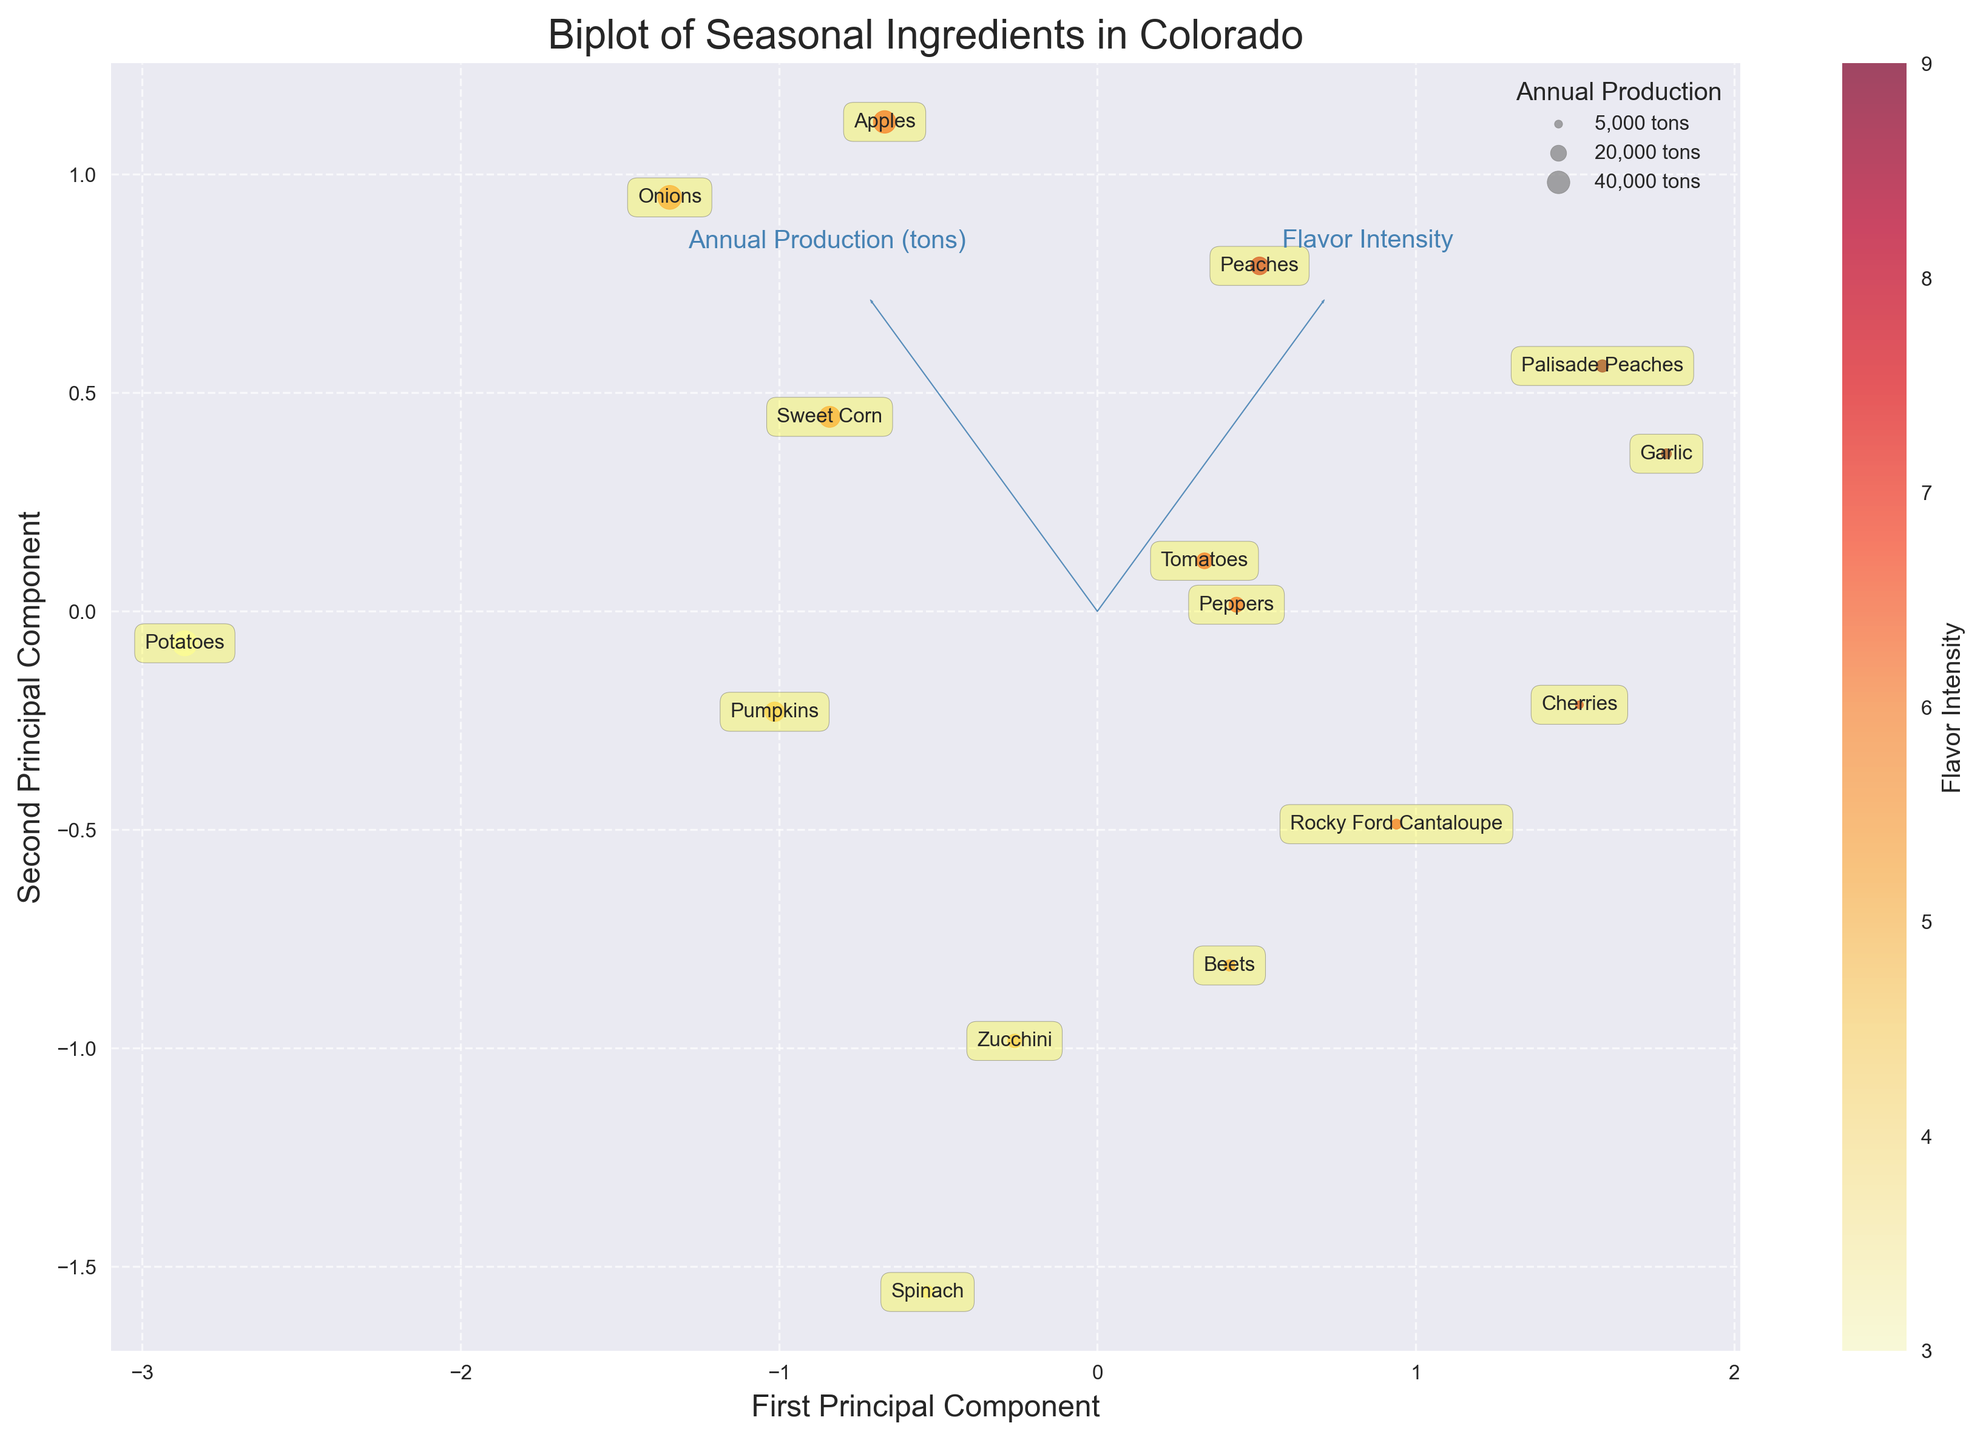What is the title of the biplot? The title of a figure is usually located at the top center of the plot. In this case, it should match what was set in the code.
Answer: Biplot of Seasonal Ingredients in Colorado How many ingredients are shown in the plot? To count the number of ingredients, look at the number of data points with labels in the plot. Each labeled point represents an ingredient.
Answer: 14 Which ingredient has the highest flavor intensity? The ingredient with the highest flavor intensity will be indicated by the color scale (cmap='YlOrRd'). Look for the darkest colored point on the plot.
Answer: Garlic What is the range of the first principal component? To determine the range of the first principal component, observe the x-axis limits marked on the plot.
Answer: Approximately -2 to 2 Which ingredient has the largest annual production? Larger circles on the plot represent ingredients with higher production volumes. Identify the circle with the largest size.
Answer: Potatoes What is the approximate production volume for Tomatoes? Identify the location of the 'Tomatoes' label and the size of the circle around it in relation to the legend provided, which denotes the production sizes.
Answer: 20,000 tons Which two ingredients peak in the same season and have similar flavor intensity? Look for points that are close together in terms of both their position on the plot (PCA dimensions) and their color (flavor intensity).
Answer: Apples and Onions What is the flavor intensity of Spinach compared to Beets? Find the positions and colors of Spinach and Beets on the plot to compare their flavor intensity; flavor intensity is represented by the color gradient on the plot.
Answer: Spinach has a lower flavor intensity than Beets How does the first principal component affect the annual production variable? Observe the direction and length of the arrow for 'Annual Production (tons)' along the first principal component. The PCA arrow indicates how the variable contributes to the component.
Answer: Positively related Which ingredients peak in the summer months (June, July, August)? Identify the labeled points on the plot and cross-reference with the 'Peak Season Start' and 'Peak Season End' data to determine which ingredients have a peak season that includes June, July, or August.
Answer: Peaches, Palisade Peaches, Rocky Ford Cantaloupe, Sweet Corn, Cherries, Tomatoes, Zucchini, Beets, Peppers 